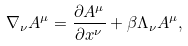Convert formula to latex. <formula><loc_0><loc_0><loc_500><loc_500>\nabla _ { \nu } A ^ { \mu } = \frac { \partial A ^ { \mu } } { \partial x ^ { \nu } } + \beta \Lambda _ { \nu } A ^ { \mu } ,</formula> 